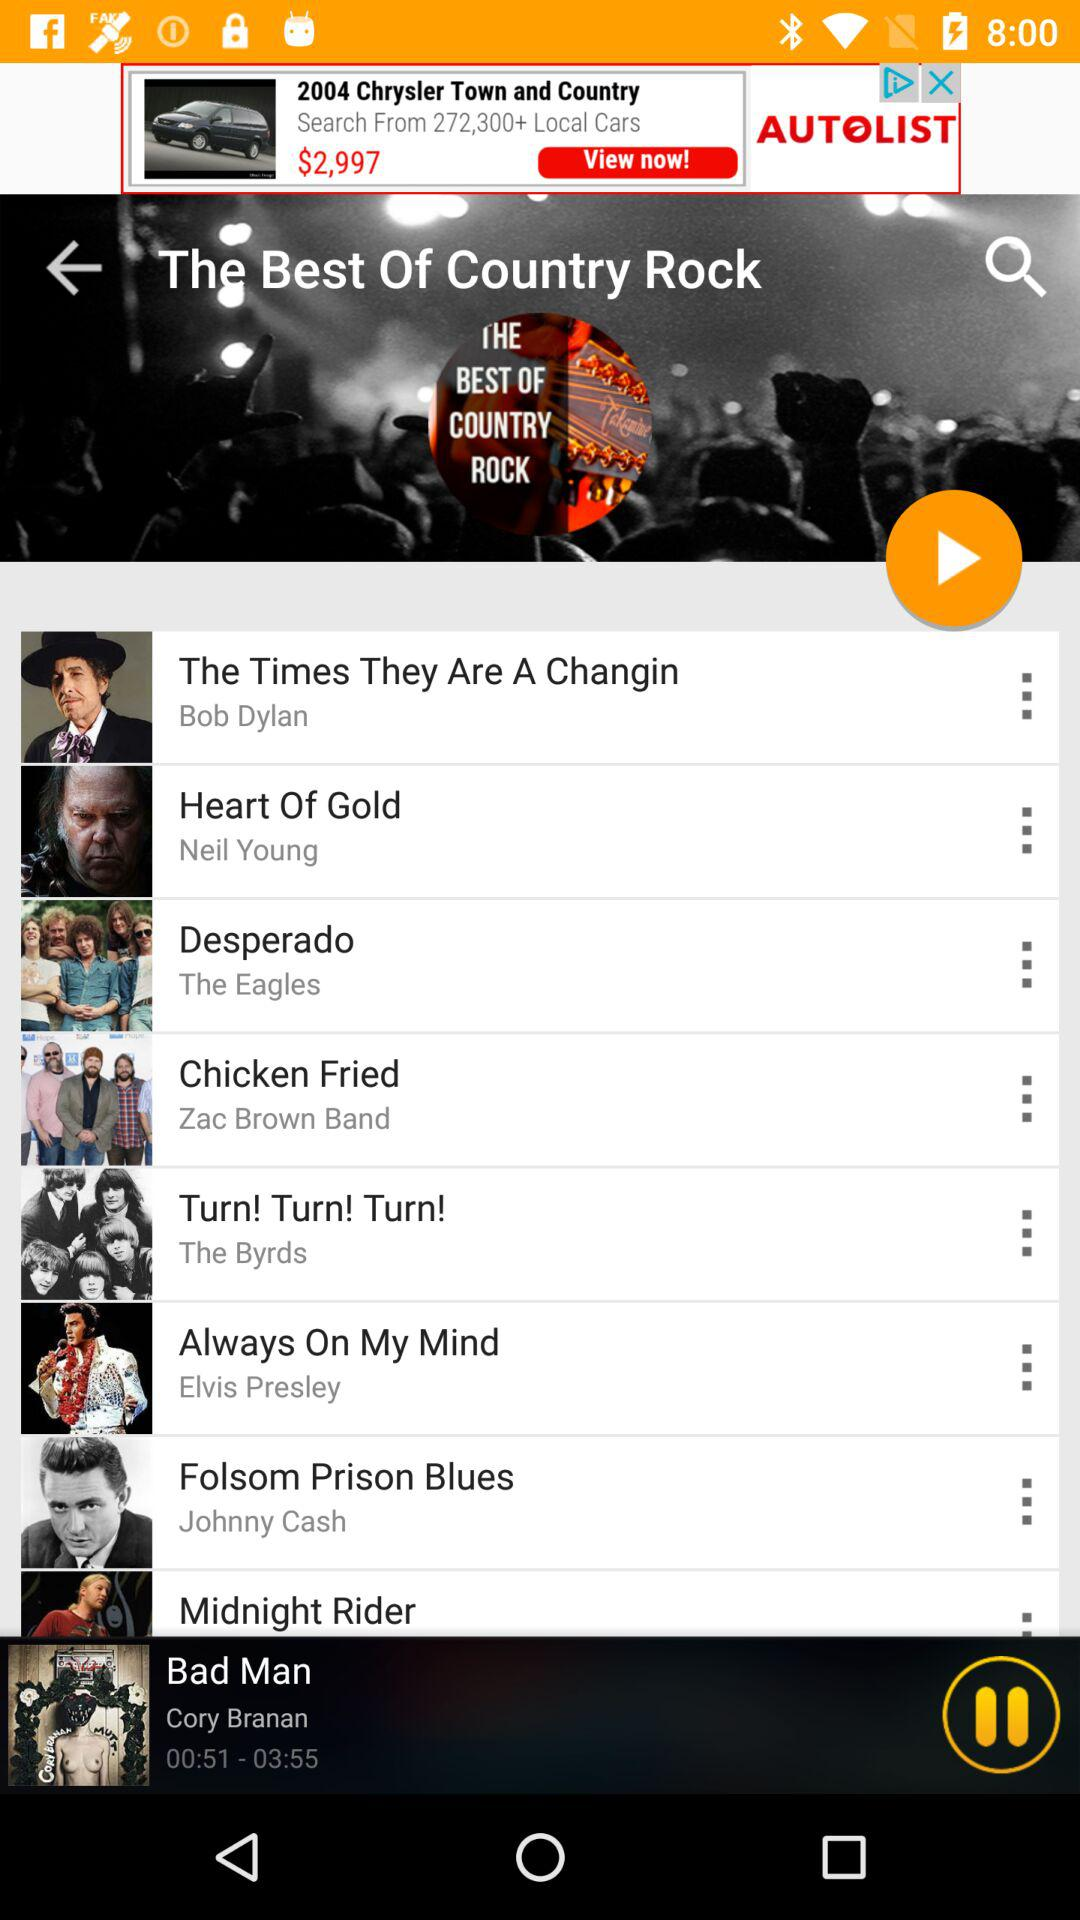Who is the singer of the song "Heart Of Gold"? The singer of the song "Heart Of Gold" is Neil Young. 